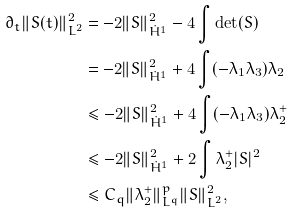<formula> <loc_0><loc_0><loc_500><loc_500>\partial _ { t } \| S ( t ) \| _ { L ^ { 2 } } ^ { 2 } & = - 2 \| S \| _ { \dot { H } ^ { 1 } } ^ { 2 } - 4 \int \det ( S ) \\ & = - 2 \| S \| _ { \dot { H } ^ { 1 } } ^ { 2 } + 4 \int ( - \lambda _ { 1 } \lambda _ { 3 } ) \lambda _ { 2 } \\ & \leq - 2 \| S \| _ { \dot { H } ^ { 1 } } ^ { 2 } + 4 \int ( - \lambda _ { 1 } \lambda _ { 3 } ) \lambda _ { 2 } ^ { + } \\ & \leq - 2 \| S \| _ { \dot { H } ^ { 1 } } ^ { 2 } + 2 \int \lambda _ { 2 } ^ { + } | S | ^ { 2 } \\ & \leq C _ { q } \| \lambda _ { 2 } ^ { + } \| _ { L ^ { q } } ^ { p } \| S \| _ { L ^ { 2 } } ^ { 2 } ,</formula> 